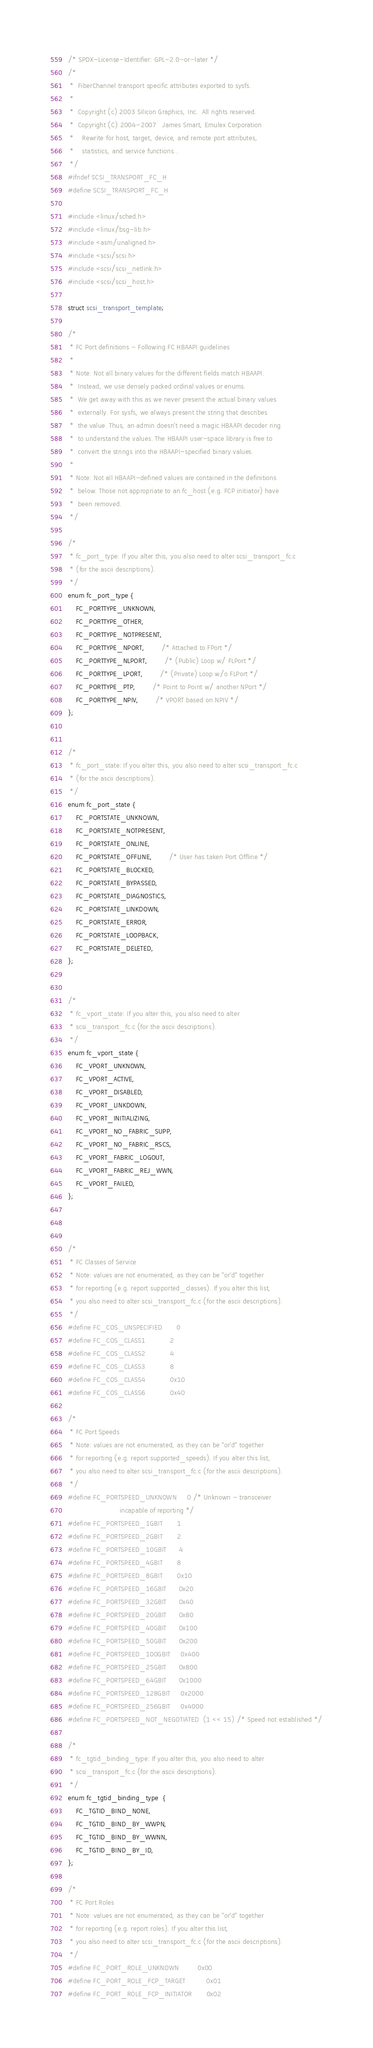<code> <loc_0><loc_0><loc_500><loc_500><_C_>/* SPDX-License-Identifier: GPL-2.0-or-later */
/*
 *  FiberChannel transport specific attributes exported to sysfs.
 *
 *  Copyright (c) 2003 Silicon Graphics, Inc.  All rights reserved.
 *  Copyright (C) 2004-2007   James Smart, Emulex Corporation
 *    Rewrite for host, target, device, and remote port attributes,
 *    statistics, and service functions...
 */
#ifndef SCSI_TRANSPORT_FC_H
#define SCSI_TRANSPORT_FC_H

#include <linux/sched.h>
#include <linux/bsg-lib.h>
#include <asm/unaligned.h>
#include <scsi/scsi.h>
#include <scsi/scsi_netlink.h>
#include <scsi/scsi_host.h>

struct scsi_transport_template;

/*
 * FC Port definitions - Following FC HBAAPI guidelines
 *
 * Note: Not all binary values for the different fields match HBAAPI.
 *  Instead, we use densely packed ordinal values or enums.
 *  We get away with this as we never present the actual binary values
 *  externally. For sysfs, we always present the string that describes
 *  the value. Thus, an admin doesn't need a magic HBAAPI decoder ring
 *  to understand the values. The HBAAPI user-space library is free to
 *  convert the strings into the HBAAPI-specified binary values.
 *
 * Note: Not all HBAAPI-defined values are contained in the definitions
 *  below. Those not appropriate to an fc_host (e.g. FCP initiator) have
 *  been removed.
 */

/*
 * fc_port_type: If you alter this, you also need to alter scsi_transport_fc.c
 * (for the ascii descriptions).
 */
enum fc_port_type {
	FC_PORTTYPE_UNKNOWN,
	FC_PORTTYPE_OTHER,
	FC_PORTTYPE_NOTPRESENT,
	FC_PORTTYPE_NPORT,		/* Attached to FPort */
	FC_PORTTYPE_NLPORT,		/* (Public) Loop w/ FLPort */
	FC_PORTTYPE_LPORT,		/* (Private) Loop w/o FLPort */
	FC_PORTTYPE_PTP,		/* Point to Point w/ another NPort */
	FC_PORTTYPE_NPIV,		/* VPORT based on NPIV */
};


/*
 * fc_port_state: If you alter this, you also need to alter scsi_transport_fc.c
 * (for the ascii descriptions).
 */
enum fc_port_state {
	FC_PORTSTATE_UNKNOWN,
	FC_PORTSTATE_NOTPRESENT,
	FC_PORTSTATE_ONLINE,
	FC_PORTSTATE_OFFLINE,		/* User has taken Port Offline */
	FC_PORTSTATE_BLOCKED,
	FC_PORTSTATE_BYPASSED,
	FC_PORTSTATE_DIAGNOSTICS,
	FC_PORTSTATE_LINKDOWN,
	FC_PORTSTATE_ERROR,
	FC_PORTSTATE_LOOPBACK,
	FC_PORTSTATE_DELETED,
};


/*
 * fc_vport_state: If you alter this, you also need to alter
 * scsi_transport_fc.c (for the ascii descriptions).
 */
enum fc_vport_state {
	FC_VPORT_UNKNOWN,
	FC_VPORT_ACTIVE,
	FC_VPORT_DISABLED,
	FC_VPORT_LINKDOWN,
	FC_VPORT_INITIALIZING,
	FC_VPORT_NO_FABRIC_SUPP,
	FC_VPORT_NO_FABRIC_RSCS,
	FC_VPORT_FABRIC_LOGOUT,
	FC_VPORT_FABRIC_REJ_WWN,
	FC_VPORT_FAILED,
};



/*
 * FC Classes of Service
 * Note: values are not enumerated, as they can be "or'd" together
 * for reporting (e.g. report supported_classes). If you alter this list,
 * you also need to alter scsi_transport_fc.c (for the ascii descriptions).
 */
#define FC_COS_UNSPECIFIED		0
#define FC_COS_CLASS1			2
#define FC_COS_CLASS2			4
#define FC_COS_CLASS3			8
#define FC_COS_CLASS4			0x10
#define FC_COS_CLASS6			0x40

/*
 * FC Port Speeds
 * Note: values are not enumerated, as they can be "or'd" together
 * for reporting (e.g. report supported_speeds). If you alter this list,
 * you also need to alter scsi_transport_fc.c (for the ascii descriptions).
 */
#define FC_PORTSPEED_UNKNOWN		0 /* Unknown - transceiver
					     incapable of reporting */
#define FC_PORTSPEED_1GBIT		1
#define FC_PORTSPEED_2GBIT		2
#define FC_PORTSPEED_10GBIT		4
#define FC_PORTSPEED_4GBIT		8
#define FC_PORTSPEED_8GBIT		0x10
#define FC_PORTSPEED_16GBIT		0x20
#define FC_PORTSPEED_32GBIT		0x40
#define FC_PORTSPEED_20GBIT		0x80
#define FC_PORTSPEED_40GBIT		0x100
#define FC_PORTSPEED_50GBIT		0x200
#define FC_PORTSPEED_100GBIT		0x400
#define FC_PORTSPEED_25GBIT		0x800
#define FC_PORTSPEED_64GBIT		0x1000
#define FC_PORTSPEED_128GBIT		0x2000
#define FC_PORTSPEED_256GBIT		0x4000
#define FC_PORTSPEED_NOT_NEGOTIATED	(1 << 15) /* Speed not established */

/*
 * fc_tgtid_binding_type: If you alter this, you also need to alter
 * scsi_transport_fc.c (for the ascii descriptions).
 */
enum fc_tgtid_binding_type  {
	FC_TGTID_BIND_NONE,
	FC_TGTID_BIND_BY_WWPN,
	FC_TGTID_BIND_BY_WWNN,
	FC_TGTID_BIND_BY_ID,
};

/*
 * FC Port Roles
 * Note: values are not enumerated, as they can be "or'd" together
 * for reporting (e.g. report roles). If you alter this list,
 * you also need to alter scsi_transport_fc.c (for the ascii descriptions).
 */
#define FC_PORT_ROLE_UNKNOWN			0x00
#define FC_PORT_ROLE_FCP_TARGET			0x01
#define FC_PORT_ROLE_FCP_INITIATOR		0x02</code> 